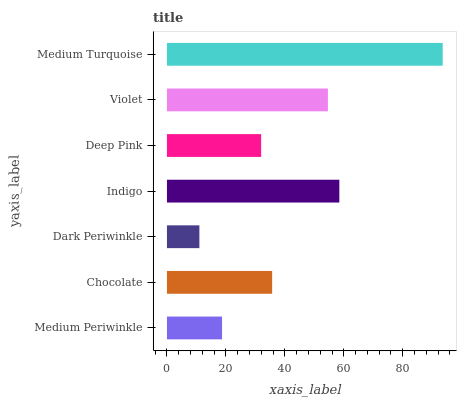Is Dark Periwinkle the minimum?
Answer yes or no. Yes. Is Medium Turquoise the maximum?
Answer yes or no. Yes. Is Chocolate the minimum?
Answer yes or no. No. Is Chocolate the maximum?
Answer yes or no. No. Is Chocolate greater than Medium Periwinkle?
Answer yes or no. Yes. Is Medium Periwinkle less than Chocolate?
Answer yes or no. Yes. Is Medium Periwinkle greater than Chocolate?
Answer yes or no. No. Is Chocolate less than Medium Periwinkle?
Answer yes or no. No. Is Chocolate the high median?
Answer yes or no. Yes. Is Chocolate the low median?
Answer yes or no. Yes. Is Indigo the high median?
Answer yes or no. No. Is Deep Pink the low median?
Answer yes or no. No. 